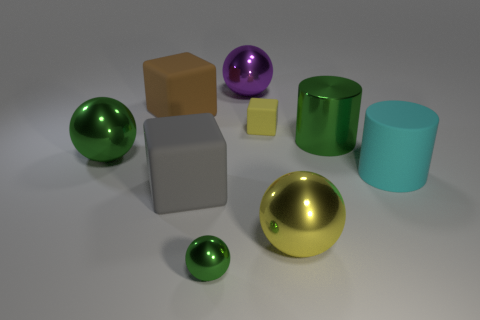Subtract all big green spheres. How many spheres are left? 3 Add 1 small metal objects. How many objects exist? 10 Subtract all green spheres. How many spheres are left? 2 Subtract all cubes. How many objects are left? 6 Subtract all purple cylinders. How many green spheres are left? 2 Add 6 large balls. How many large balls are left? 9 Add 4 small yellow rubber objects. How many small yellow rubber objects exist? 5 Subtract 0 gray spheres. How many objects are left? 9 Subtract 1 cubes. How many cubes are left? 2 Subtract all cyan balls. Subtract all red blocks. How many balls are left? 4 